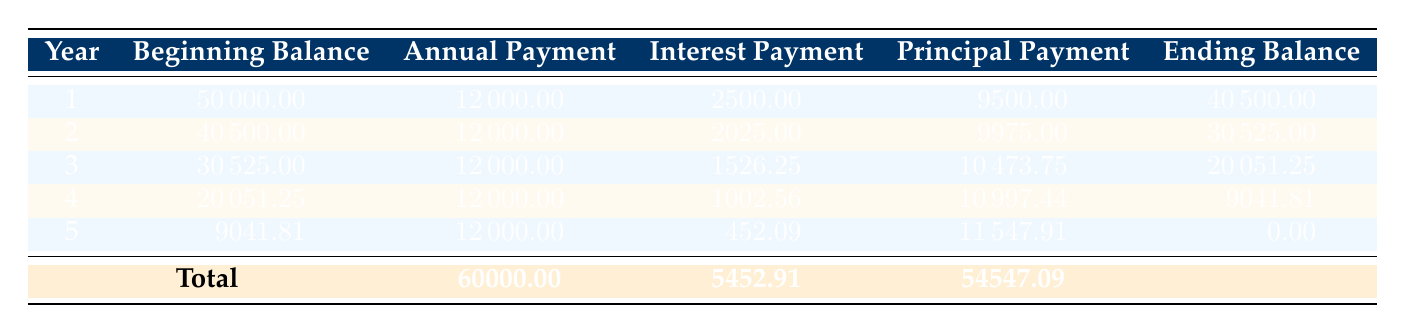What is the total annual payment over the 5 years? The table shows that the annual payment is consistently 12000 each year. To find the total payment, we multiply the annual payment by the number of years: 12000 * 5 = 60000.
Answer: 60000 What was the interest payment in the first year? Referring to the first row of the table, the interest payment for year 1 is explicitly listed as 2500.
Answer: 2500 How much principal was paid off in the last year? In the fifth row, the principal payment for year 5 is stated as 11547.91.
Answer: 11547.91 Is the total interest paid over the 5 years more than 5000? The total interest paid is listed as 5452.91 in the last row of the table. Since 5452.91 is greater than 5000, the statement is true.
Answer: Yes What is the average annual principal payment over the 5 years? To find the average, we sum the principal payments across all 5 years: 9500 + 9975 + 10473.75 + 10997.44 + 11547.91 = 54547.1. Then we divide by 5: 54547.1 / 5 = 10909.42.
Answer: 10909.42 What was the ending balance at the end of year 3? From the third row, the ending balance after year 3 is shown as 20051.25, which is directly stated in the table.
Answer: 20051.25 What is the total principal paid off by year 3? By examining the table, we see the principal payments for the first three years are 9500, 9975, and 10473.75. We sum these amounts: 9500 + 9975 + 10473.75 = 29948.75.
Answer: 29948.75 Was the annual payment the same in every year? By inspecting the annual payment column, we see the value is consistently 12000 in each year, confirming the statement is true.
Answer: Yes 